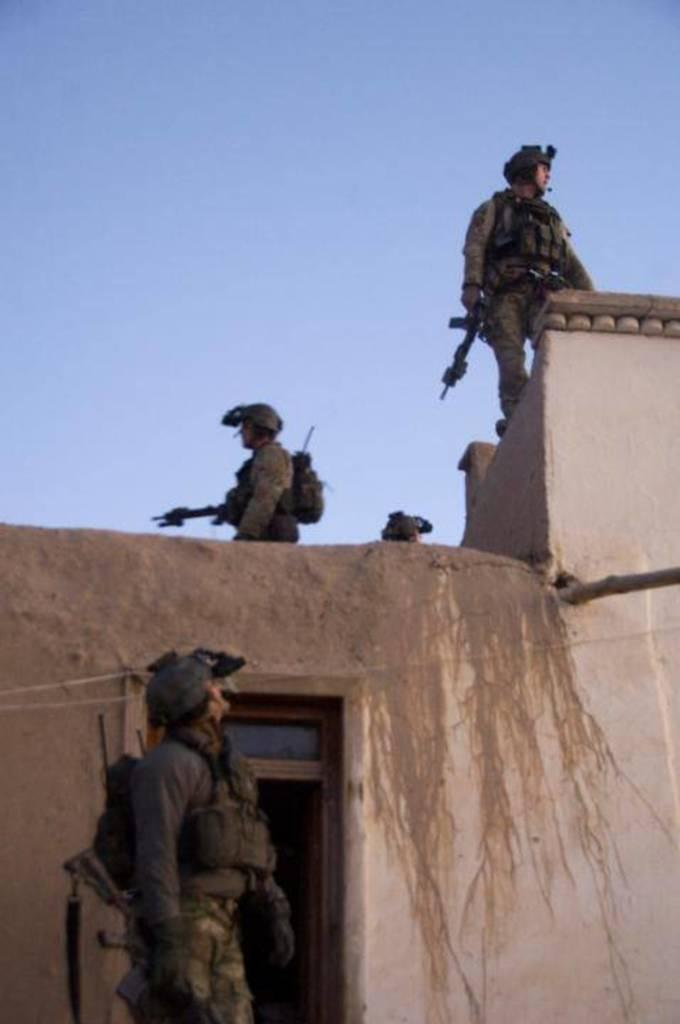How many people are in the image? There are people in the image, specifically three persons. What are the three persons holding in the image? The three persons are holding guns in the image. Where are the three persons standing in the image? The three persons are standing on a wall in the image. What is visible in the background of the image? The sky is visible in the image. What type of oil can be seen dripping from the bag in the image? There is no bag or oil present in the image. How many bushes are visible in the image? There are no bushes visible in the image. 